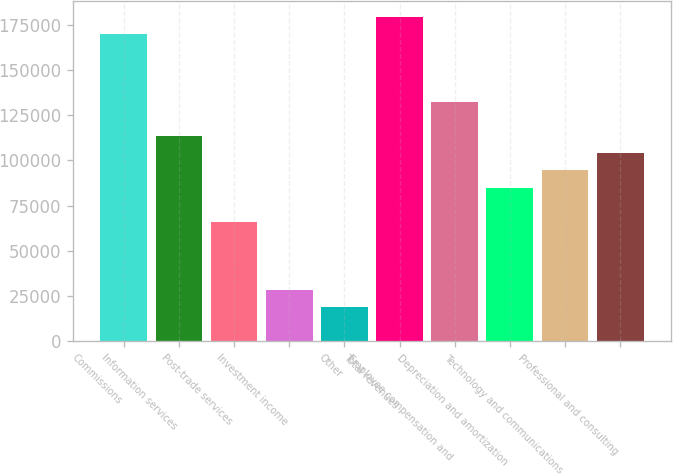<chart> <loc_0><loc_0><loc_500><loc_500><bar_chart><fcel>Commissions<fcel>Information services<fcel>Post-trade services<fcel>Investment income<fcel>Other<fcel>Total revenues<fcel>Employee compensation and<fcel>Depreciation and amortization<fcel>Technology and communications<fcel>Professional and consulting<nl><fcel>169984<fcel>113323<fcel>66105.4<fcel>28331.4<fcel>18887.9<fcel>179428<fcel>132210<fcel>84992.5<fcel>94436<fcel>103879<nl></chart> 